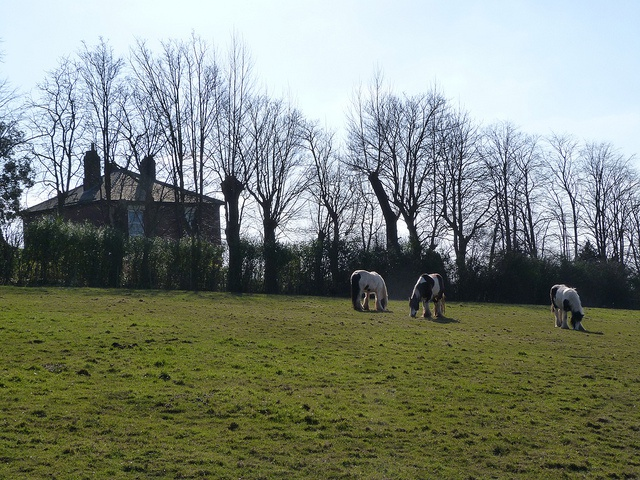Describe the objects in this image and their specific colors. I can see horse in white, black, gray, and darkgray tones, horse in lavender, black, and gray tones, and horse in white, black, and gray tones in this image. 